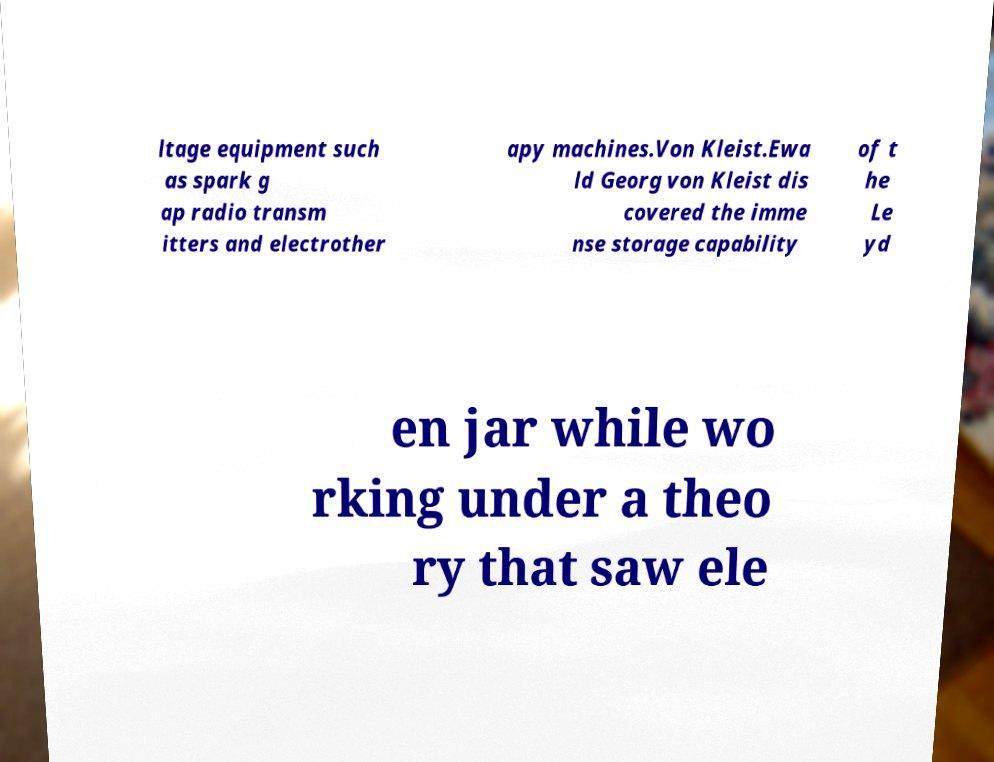Can you accurately transcribe the text from the provided image for me? ltage equipment such as spark g ap radio transm itters and electrother apy machines.Von Kleist.Ewa ld Georg von Kleist dis covered the imme nse storage capability of t he Le yd en jar while wo rking under a theo ry that saw ele 